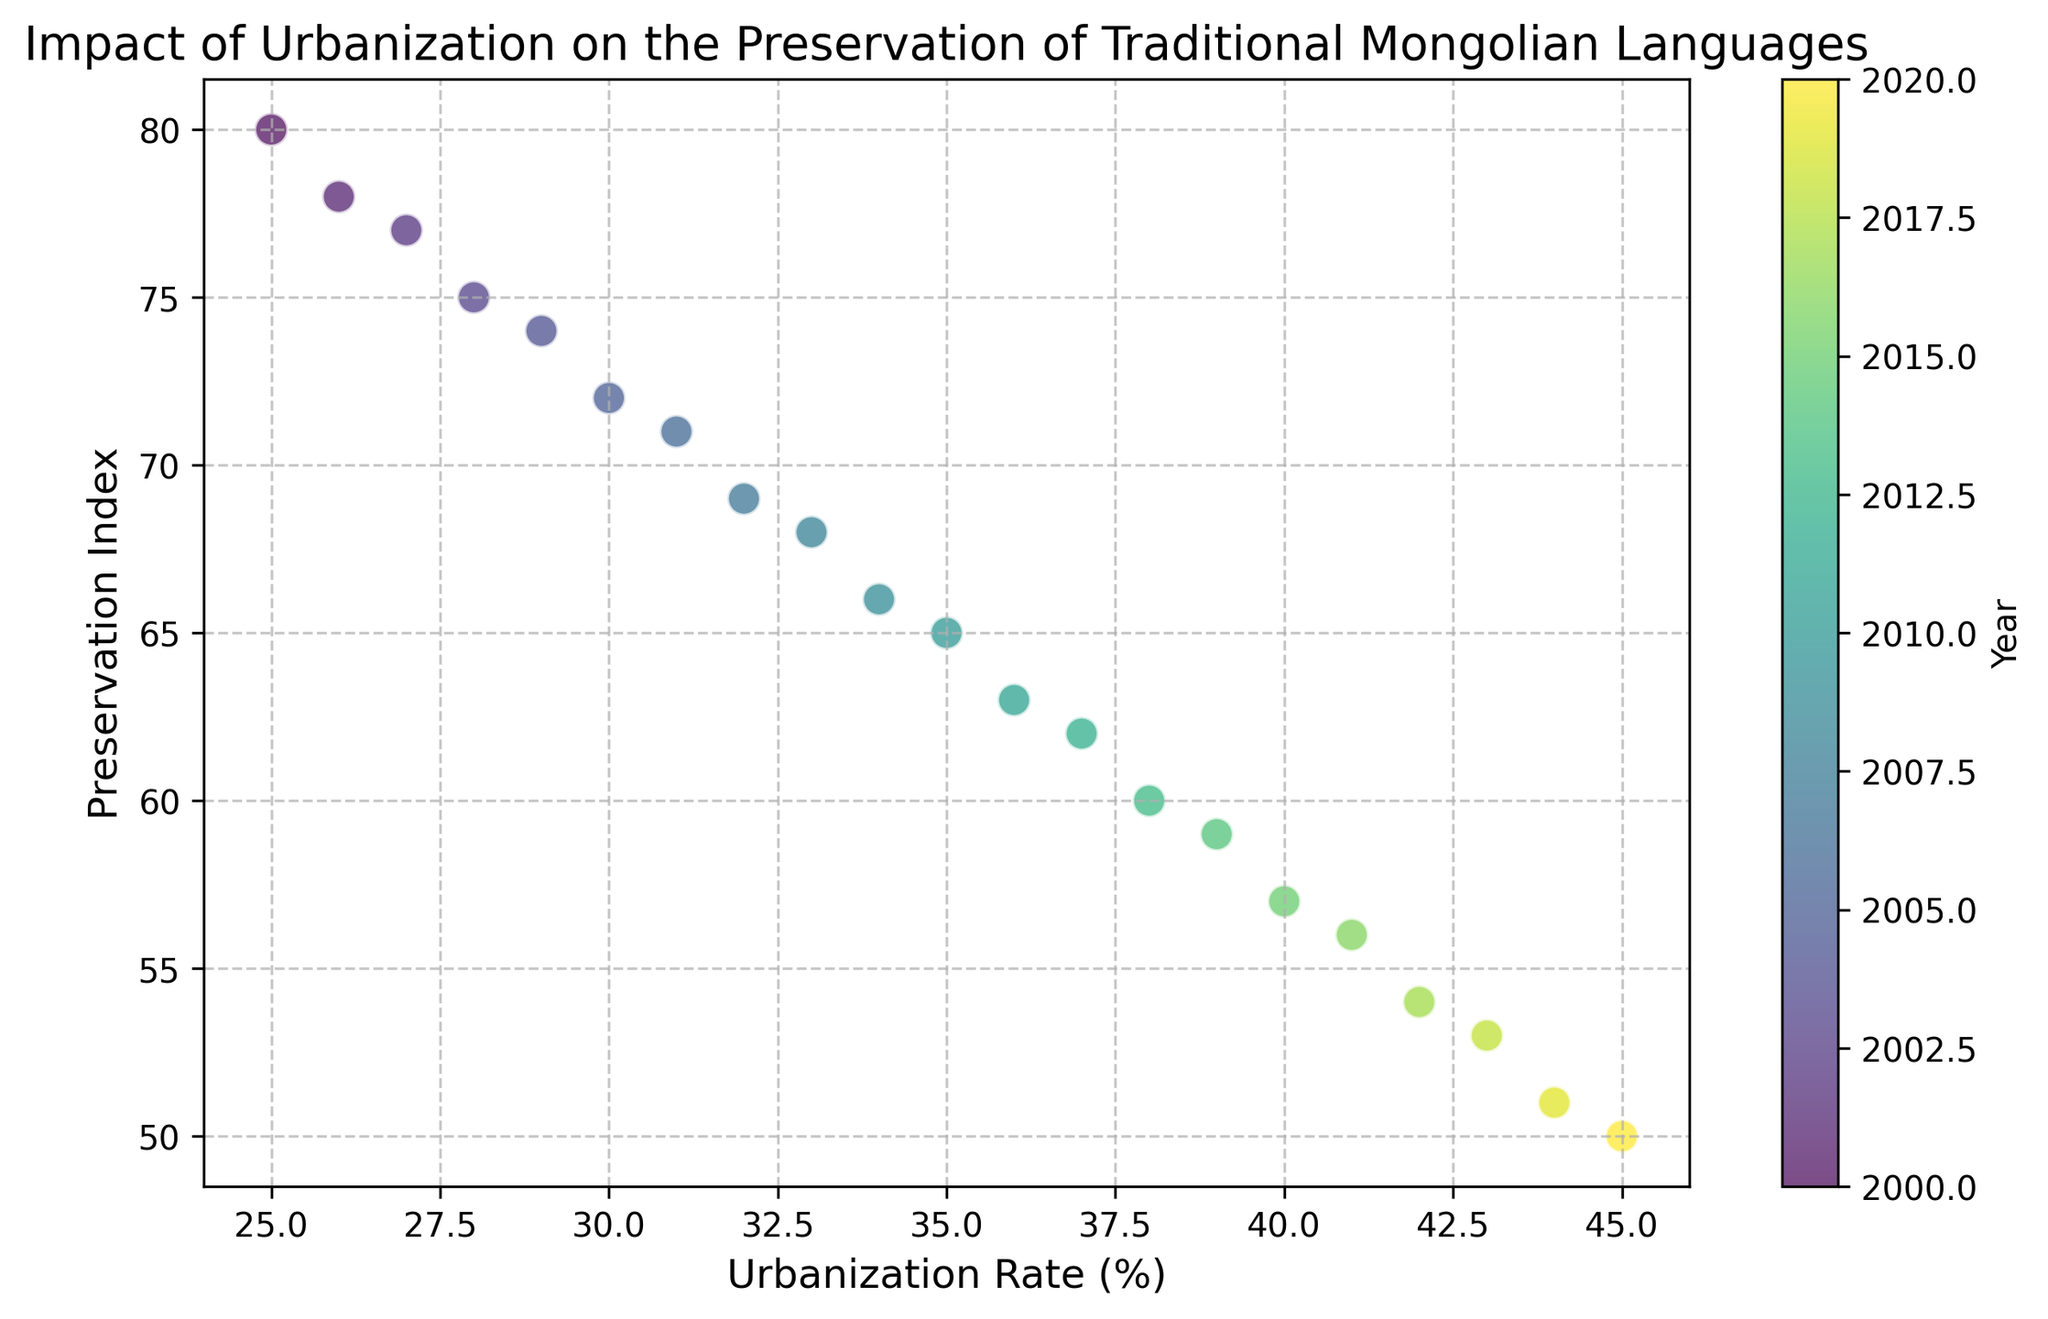What's the general trend shown in the scatter plot? Observing the scatter plot, as the urbanization rate increases, the preservation index of traditional Mongolian languages tends to decrease. This indicates a negative correlation.
Answer: The preservation index decreases as the urbanization rate increases Which year corresponds to the highest level of traditional Mongolian language preservation? The scatter plot uses color to represent different years, and the point with the highest preservation index (80) corresponds to the year 2000 as indicated by the color bar.
Answer: 2000 What is the preservation index when the urbanization rate is 45%? By locating the point where the urbanization rate is 45% on the x-axis, we see that it corresponds to a preservation index of 50, as per the y-axis value.
Answer: 50 Between which two years does the preservation index drop the most? By examining the slope between points year by year, the largest vertical drop on the scatter plot occurs from 2009 to 2010, where the preservation index drops from 66 to 65.
Answer: 2009 to 2010 If the urbanization rate increases by 10%, by how much does the preservation index typically decrease based on the plot? By analyzing the general trend of data points between urbanization rates of 25% to 45%, a 10% increase in urbanization rate roughly corresponds to about a 15% decrease in the preservation index. This is found by noting the overall decrease from 80 to 50 over a 20% urbanization increase (yielding about 30% decrease over 20%, which averages to around 15% decrease per 10%).
Answer: About 15% Does the scatter plot exhibit any outliers or unusual data points? All points seem to follow a consistent downward trend. There are no clear outliers that deviate significantly from the trend line represented.
Answer: No How does the preservation index change from 2015 to 2018? From the data points, the preservation index decreases from 57 in 2015 to 53 in 2018, marking a decline of 4 units over those three years.
Answer: Decreases by 4 units Which year shows a preservation index of 60? By observing the vertical position labeled 60 on the y-axis and identifying the corresponding colored point, the year shown is 2013 as indicated by the color bar.
Answer: 2013 By how many units does the preservation index decrease when comparing the years 2000 and 2020? The preservation index is 80 for the year 2000 and 50 for the year 2020. The difference is calculated as 80 - 50.
Answer: 30 units If the preservation index continues to decrease with the same pattern, what would you predict the preservation index to be if the urbanization rate increases to 50% by, say 2025? Following the trend line, for each 1% increase in urbanization, the preservation index decreases roughly by 1.5 units. If urbanization reaches 50%, an additional 5% (from 45%) would decrease the preservation index by about 7.5 units, making it roughly 42.5.
Answer: Approximately 42.5 